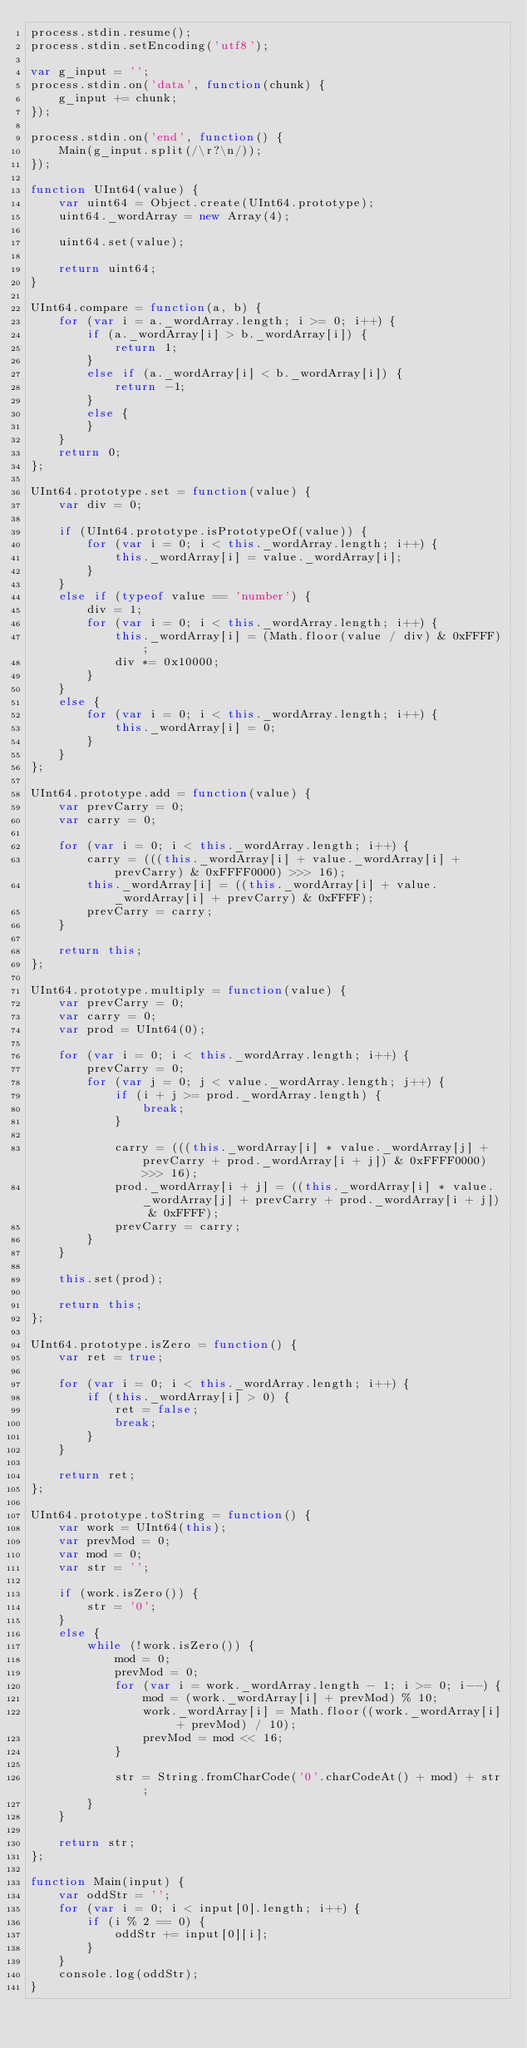Convert code to text. <code><loc_0><loc_0><loc_500><loc_500><_JavaScript_>process.stdin.resume();
process.stdin.setEncoding('utf8');

var g_input = '';
process.stdin.on('data', function(chunk) {
    g_input += chunk;
});

process.stdin.on('end', function() {
    Main(g_input.split(/\r?\n/));
});

function UInt64(value) {
    var uint64 = Object.create(UInt64.prototype);
    uint64._wordArray = new Array(4);

    uint64.set(value);

    return uint64;
}

UInt64.compare = function(a, b) {
    for (var i = a._wordArray.length; i >= 0; i++) {
        if (a._wordArray[i] > b._wordArray[i]) {
            return 1;
        }
        else if (a._wordArray[i] < b._wordArray[i]) {
            return -1;
        }
        else {
        }
    }
    return 0;
};

UInt64.prototype.set = function(value) {
    var div = 0;

    if (UInt64.prototype.isPrototypeOf(value)) {
        for (var i = 0; i < this._wordArray.length; i++) {
            this._wordArray[i] = value._wordArray[i];
        }
    }
    else if (typeof value == 'number') {
        div = 1;
        for (var i = 0; i < this._wordArray.length; i++) {
            this._wordArray[i] = (Math.floor(value / div) & 0xFFFF);
            div *= 0x10000;
        }
    }
    else {
        for (var i = 0; i < this._wordArray.length; i++) {
            this._wordArray[i] = 0;
        }
    }
};

UInt64.prototype.add = function(value) {
    var prevCarry = 0;
    var carry = 0;

    for (var i = 0; i < this._wordArray.length; i++) {
        carry = (((this._wordArray[i] + value._wordArray[i] + prevCarry) & 0xFFFF0000) >>> 16);
        this._wordArray[i] = ((this._wordArray[i] + value._wordArray[i] + prevCarry) & 0xFFFF);
        prevCarry = carry;
    }

    return this;
};

UInt64.prototype.multiply = function(value) {
    var prevCarry = 0;
    var carry = 0;
    var prod = UInt64(0);

    for (var i = 0; i < this._wordArray.length; i++) {
        prevCarry = 0;
        for (var j = 0; j < value._wordArray.length; j++) {
            if (i + j >= prod._wordArray.length) {
                break;
            }

            carry = (((this._wordArray[i] * value._wordArray[j] + prevCarry + prod._wordArray[i + j]) & 0xFFFF0000) >>> 16);
            prod._wordArray[i + j] = ((this._wordArray[i] * value._wordArray[j] + prevCarry + prod._wordArray[i + j]) & 0xFFFF);
            prevCarry = carry;
        }
    }

    this.set(prod);

    return this;
};

UInt64.prototype.isZero = function() {
    var ret = true;

    for (var i = 0; i < this._wordArray.length; i++) {
        if (this._wordArray[i] > 0) {
            ret = false;
            break;
        }
    }

    return ret;
};

UInt64.prototype.toString = function() {
    var work = UInt64(this);
    var prevMod = 0;
    var mod = 0;
    var str = '';

    if (work.isZero()) {
        str = '0';
    }
    else {
        while (!work.isZero()) {
            mod = 0;
            prevMod = 0;
            for (var i = work._wordArray.length - 1; i >= 0; i--) {
                mod = (work._wordArray[i] + prevMod) % 10;
                work._wordArray[i] = Math.floor((work._wordArray[i] + prevMod) / 10);
                prevMod = mod << 16;
            }

            str = String.fromCharCode('0'.charCodeAt() + mod) + str;
        }
    }

    return str;
};

function Main(input) {
    var oddStr = '';
    for (var i = 0; i < input[0].length; i++) {
        if (i % 2 == 0) {
            oddStr += input[0][i];
        }
    }
    console.log(oddStr);
}
</code> 